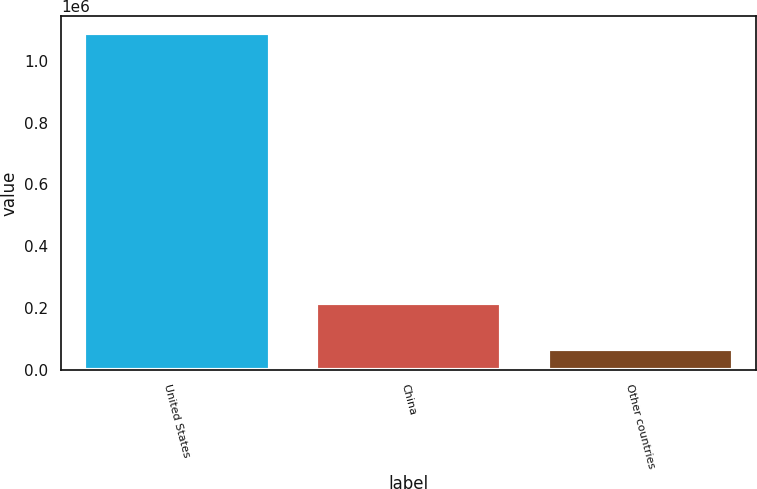Convert chart to OTSL. <chart><loc_0><loc_0><loc_500><loc_500><bar_chart><fcel>United States<fcel>China<fcel>Other countries<nl><fcel>1.08916e+06<fcel>217205<fcel>67750<nl></chart> 